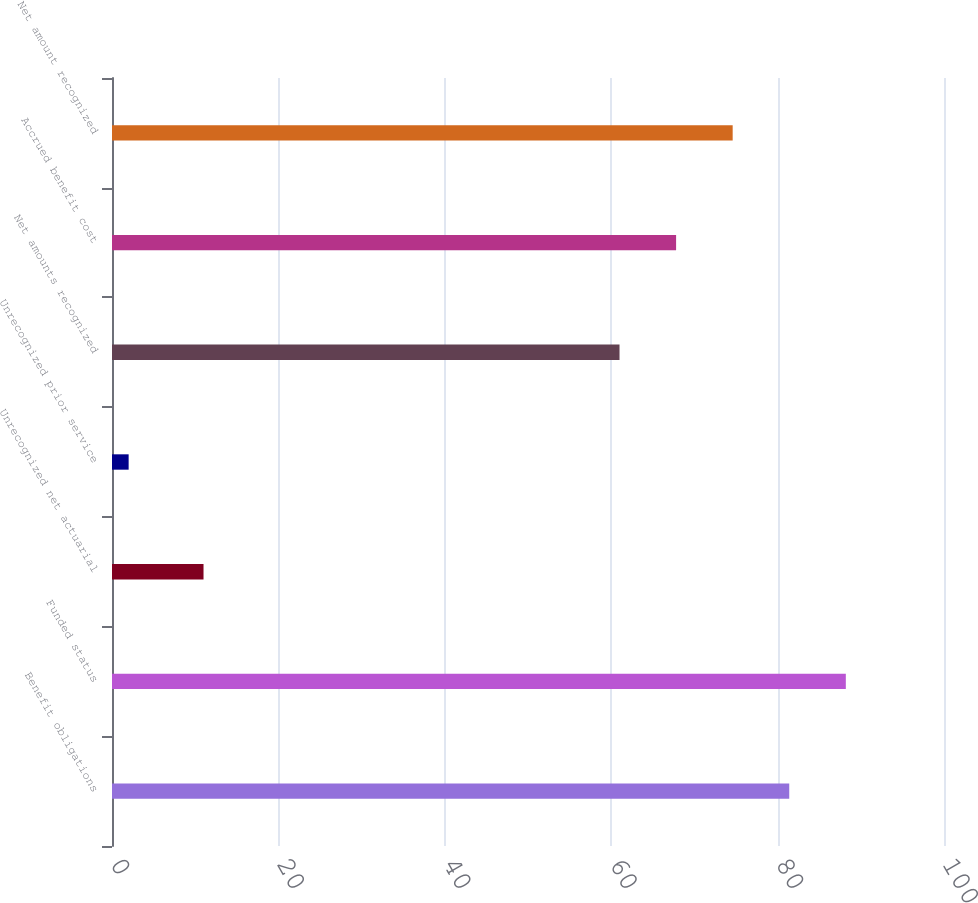<chart> <loc_0><loc_0><loc_500><loc_500><bar_chart><fcel>Benefit obligations<fcel>Funded status<fcel>Unrecognized net actuarial<fcel>Unrecognized prior service<fcel>Net amounts recognized<fcel>Accrued benefit cost<fcel>Net amount recognized<nl><fcel>81.4<fcel>88.2<fcel>11<fcel>2<fcel>61<fcel>67.8<fcel>74.6<nl></chart> 